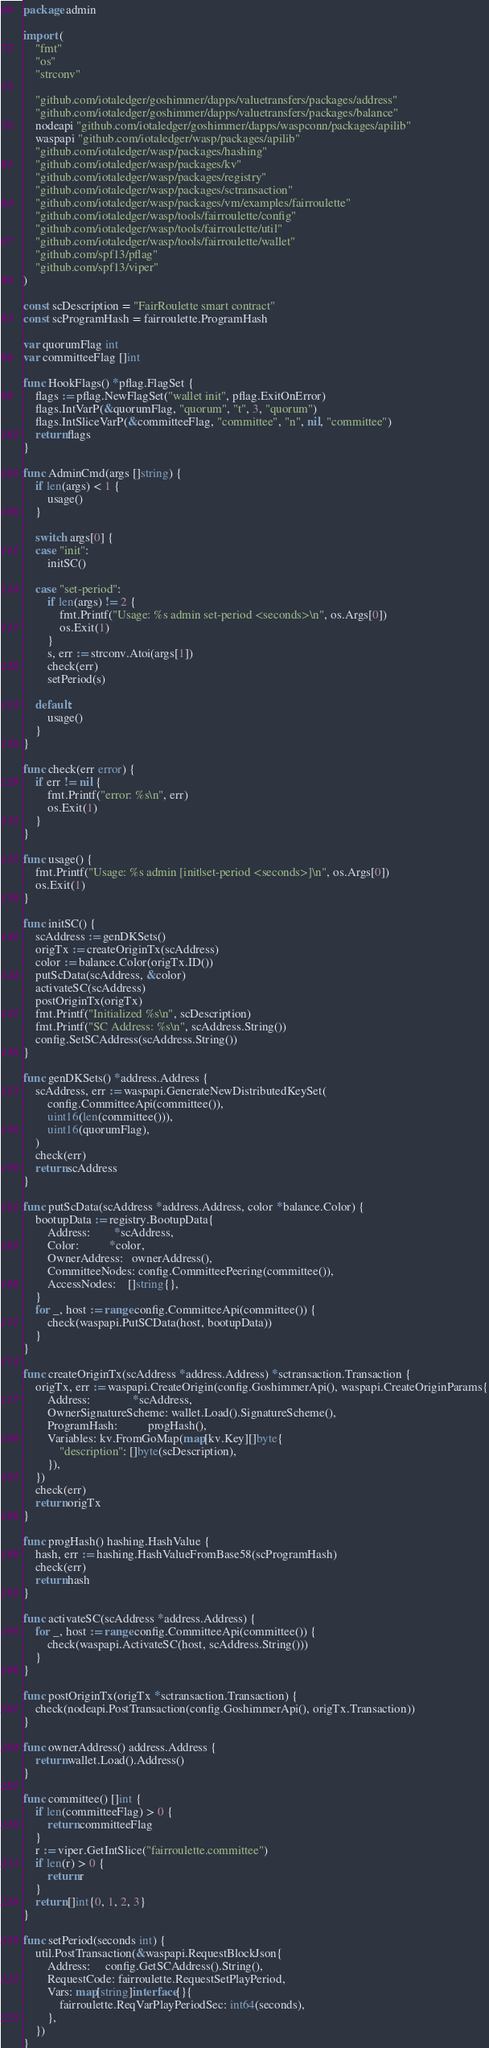<code> <loc_0><loc_0><loc_500><loc_500><_Go_>package admin

import (
	"fmt"
	"os"
	"strconv"

	"github.com/iotaledger/goshimmer/dapps/valuetransfers/packages/address"
	"github.com/iotaledger/goshimmer/dapps/valuetransfers/packages/balance"
	nodeapi "github.com/iotaledger/goshimmer/dapps/waspconn/packages/apilib"
	waspapi "github.com/iotaledger/wasp/packages/apilib"
	"github.com/iotaledger/wasp/packages/hashing"
	"github.com/iotaledger/wasp/packages/kv"
	"github.com/iotaledger/wasp/packages/registry"
	"github.com/iotaledger/wasp/packages/sctransaction"
	"github.com/iotaledger/wasp/packages/vm/examples/fairroulette"
	"github.com/iotaledger/wasp/tools/fairroulette/config"
	"github.com/iotaledger/wasp/tools/fairroulette/util"
	"github.com/iotaledger/wasp/tools/fairroulette/wallet"
	"github.com/spf13/pflag"
	"github.com/spf13/viper"
)

const scDescription = "FairRoulette smart contract"
const scProgramHash = fairroulette.ProgramHash

var quorumFlag int
var committeeFlag []int

func HookFlags() *pflag.FlagSet {
	flags := pflag.NewFlagSet("wallet init", pflag.ExitOnError)
	flags.IntVarP(&quorumFlag, "quorum", "t", 3, "quorum")
	flags.IntSliceVarP(&committeeFlag, "committee", "n", nil, "committee")
	return flags
}

func AdminCmd(args []string) {
	if len(args) < 1 {
		usage()
	}

	switch args[0] {
	case "init":
		initSC()

	case "set-period":
		if len(args) != 2 {
			fmt.Printf("Usage: %s admin set-period <seconds>\n", os.Args[0])
			os.Exit(1)
		}
		s, err := strconv.Atoi(args[1])
		check(err)
		setPeriod(s)

	default:
		usage()
	}
}

func check(err error) {
	if err != nil {
		fmt.Printf("error: %s\n", err)
		os.Exit(1)
	}
}

func usage() {
	fmt.Printf("Usage: %s admin [init|set-period <seconds>]\n", os.Args[0])
	os.Exit(1)
}

func initSC() {
	scAddress := genDKSets()
	origTx := createOriginTx(scAddress)
	color := balance.Color(origTx.ID())
	putScData(scAddress, &color)
	activateSC(scAddress)
	postOriginTx(origTx)
	fmt.Printf("Initialized %s\n", scDescription)
	fmt.Printf("SC Address: %s\n", scAddress.String())
	config.SetSCAddress(scAddress.String())
}

func genDKSets() *address.Address {
	scAddress, err := waspapi.GenerateNewDistributedKeySet(
		config.CommitteeApi(committee()),
		uint16(len(committee())),
		uint16(quorumFlag),
	)
	check(err)
	return scAddress
}

func putScData(scAddress *address.Address, color *balance.Color) {
	bootupData := registry.BootupData{
		Address:        *scAddress,
		Color:          *color,
		OwnerAddress:   ownerAddress(),
		CommitteeNodes: config.CommitteePeering(committee()),
		AccessNodes:    []string{},
	}
	for _, host := range config.CommitteeApi(committee()) {
		check(waspapi.PutSCData(host, bootupData))
	}
}

func createOriginTx(scAddress *address.Address) *sctransaction.Transaction {
	origTx, err := waspapi.CreateOrigin(config.GoshimmerApi(), waspapi.CreateOriginParams{
		Address:              *scAddress,
		OwnerSignatureScheme: wallet.Load().SignatureScheme(),
		ProgramHash:          progHash(),
		Variables: kv.FromGoMap(map[kv.Key][]byte{
			"description": []byte(scDescription),
		}),
	})
	check(err)
	return origTx
}

func progHash() hashing.HashValue {
	hash, err := hashing.HashValueFromBase58(scProgramHash)
	check(err)
	return hash
}

func activateSC(scAddress *address.Address) {
	for _, host := range config.CommitteeApi(committee()) {
		check(waspapi.ActivateSC(host, scAddress.String()))
	}
}

func postOriginTx(origTx *sctransaction.Transaction) {
	check(nodeapi.PostTransaction(config.GoshimmerApi(), origTx.Transaction))
}

func ownerAddress() address.Address {
	return wallet.Load().Address()
}

func committee() []int {
	if len(committeeFlag) > 0 {
		return committeeFlag
	}
	r := viper.GetIntSlice("fairroulette.committee")
	if len(r) > 0 {
		return r
	}
	return []int{0, 1, 2, 3}
}

func setPeriod(seconds int) {
	util.PostTransaction(&waspapi.RequestBlockJson{
		Address:     config.GetSCAddress().String(),
		RequestCode: fairroulette.RequestSetPlayPeriod,
		Vars: map[string]interface{}{
			fairroulette.ReqVarPlayPeriodSec: int64(seconds),
		},
	})
}
</code> 